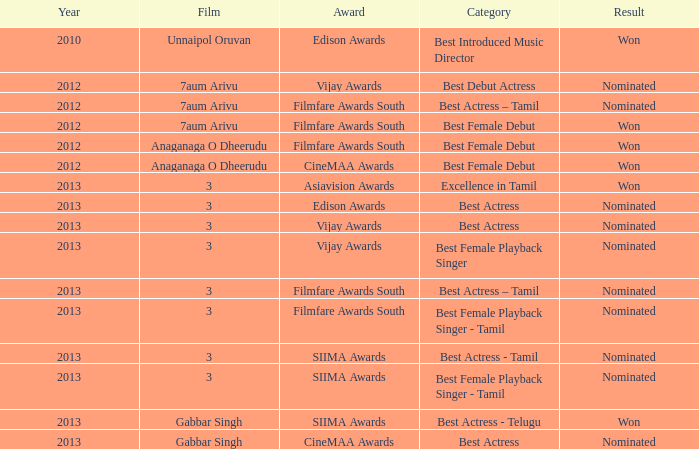What was the award for the excellence in tamil category? Asiavision Awards. 